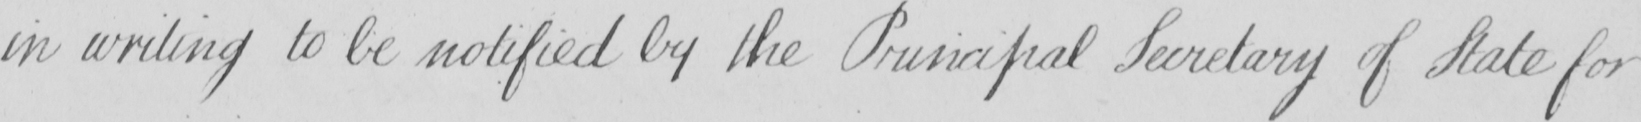Please transcribe the handwritten text in this image. in writing to be notified by the Principal Secretary of State for 